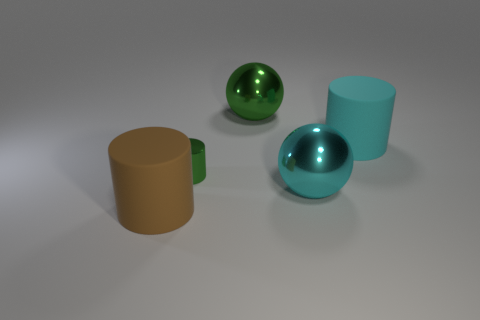Subtract all tiny cylinders. How many cylinders are left? 2 Subtract all cyan cylinders. How many cylinders are left? 2 Subtract all cylinders. How many objects are left? 2 Add 4 cyan matte cylinders. How many objects exist? 9 Subtract 1 balls. How many balls are left? 1 Subtract all purple cylinders. How many green balls are left? 1 Subtract all small purple matte cylinders. Subtract all cyan balls. How many objects are left? 4 Add 2 large shiny things. How many large shiny things are left? 4 Add 3 big cyan cylinders. How many big cyan cylinders exist? 4 Subtract 0 gray spheres. How many objects are left? 5 